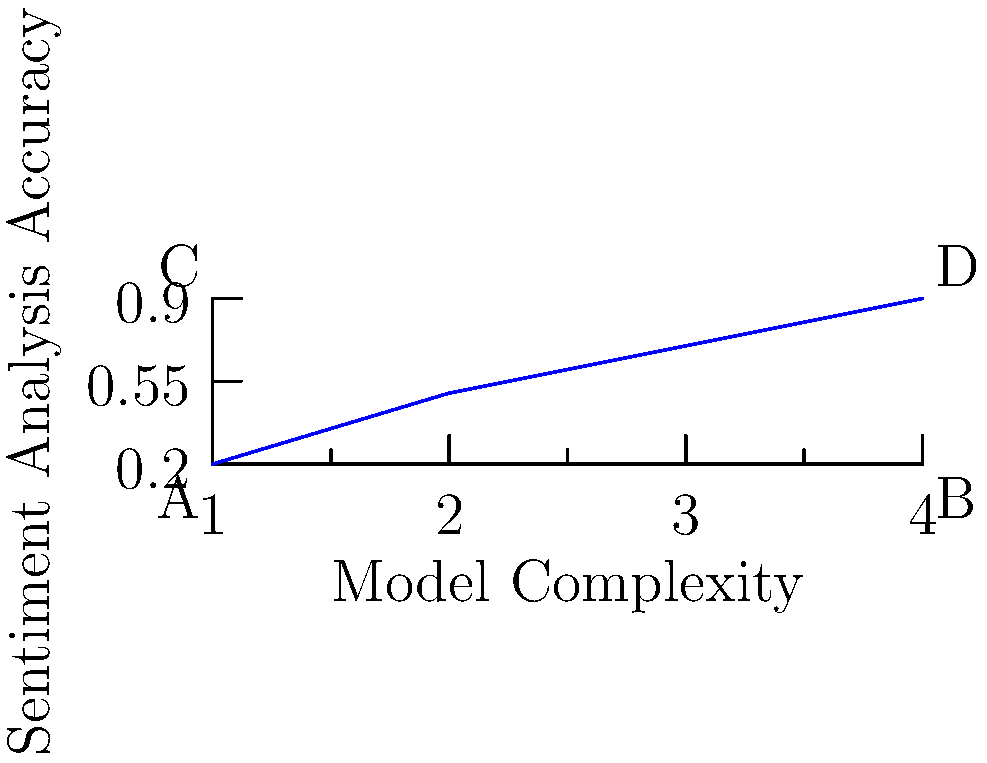The graph shows the relationship between model complexity and sentiment analysis accuracy for prison policies related to transgender rights. Which point on the graph represents the optimal balance between model complexity and accuracy for practical implementation in policy analysis? To determine the optimal point for practical implementation, we need to consider the trade-off between model complexity and accuracy:

1. Point A (bottom-left): Low complexity, low accuracy. Not ideal as it lacks precision.
2. Point B (bottom-right): High complexity, low accuracy. Inefficient use of resources.
3. Point C (top-left): Low complexity, high accuracy. This represents an efficient model.
4. Point D (top-right): High complexity, high accuracy. While accurate, it may be computationally expensive.

The optimal balance typically occurs at the "elbow" of the curve, where increasing complexity yields diminishing returns in accuracy. In this graph, point C represents this balance:

1. It achieves high accuracy (close to the maximum).
2. It maintains relatively low complexity, making it computationally efficient.
3. It provides the best trade-off between accuracy and resource utilization.

For practical implementation in policy analysis, we want a model that is both accurate and efficient. Point C satisfies these criteria, making it the optimal choice for analyzing sentiment in prison policies related to transgender rights.
Answer: Point C 